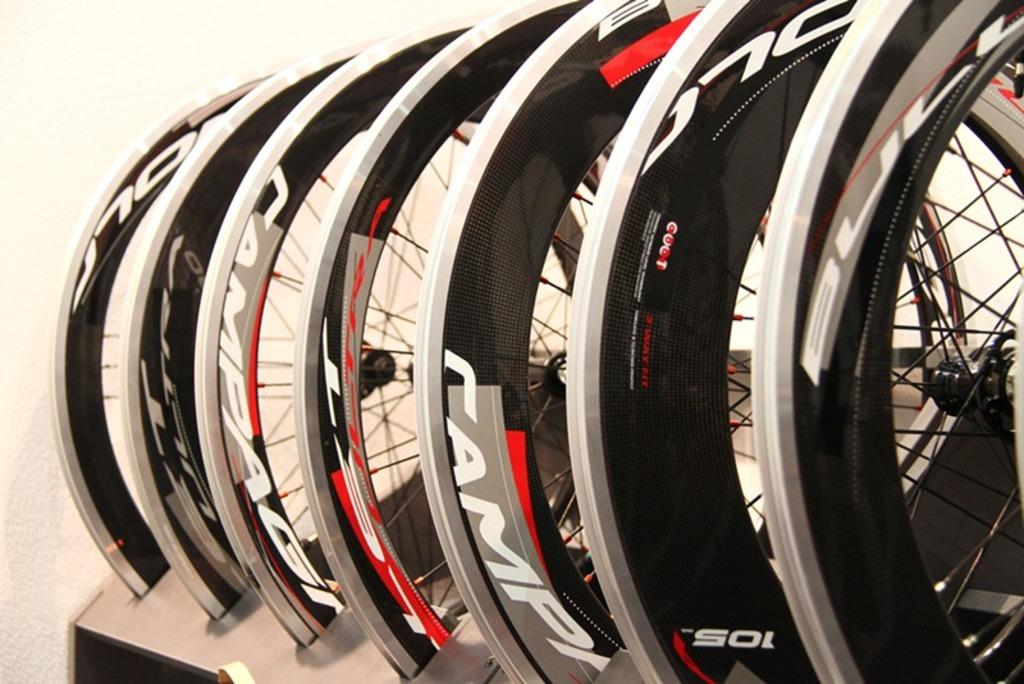What is the main subject of the image? The main subject of the image is cycle wheels. Where are the cycle wheels located? The cycle wheels are in a stand. What can be seen in the background of the image? There is a wall visible in the background of the image. What type of scissors can be seen cutting the brain in the image? There are no scissors or brain present in the image; it only features cycle wheels in a stand and a wall in the background. 